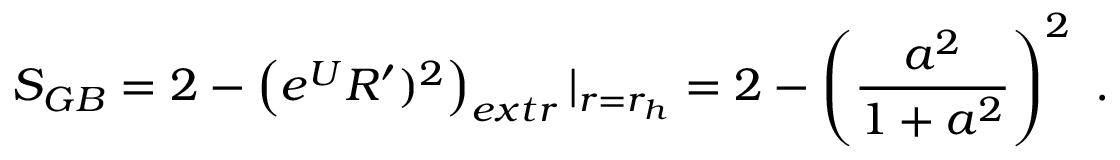<formula> <loc_0><loc_0><loc_500><loc_500>S _ { G B } = 2 - \left ( e ^ { U } R ^ { \prime } ) ^ { 2 } \right ) _ { e x t r } | _ { r = r _ { h } } = 2 - \left ( { \frac { a ^ { 2 } } { 1 + a ^ { 2 } } } \right ) ^ { 2 } \ .</formula> 